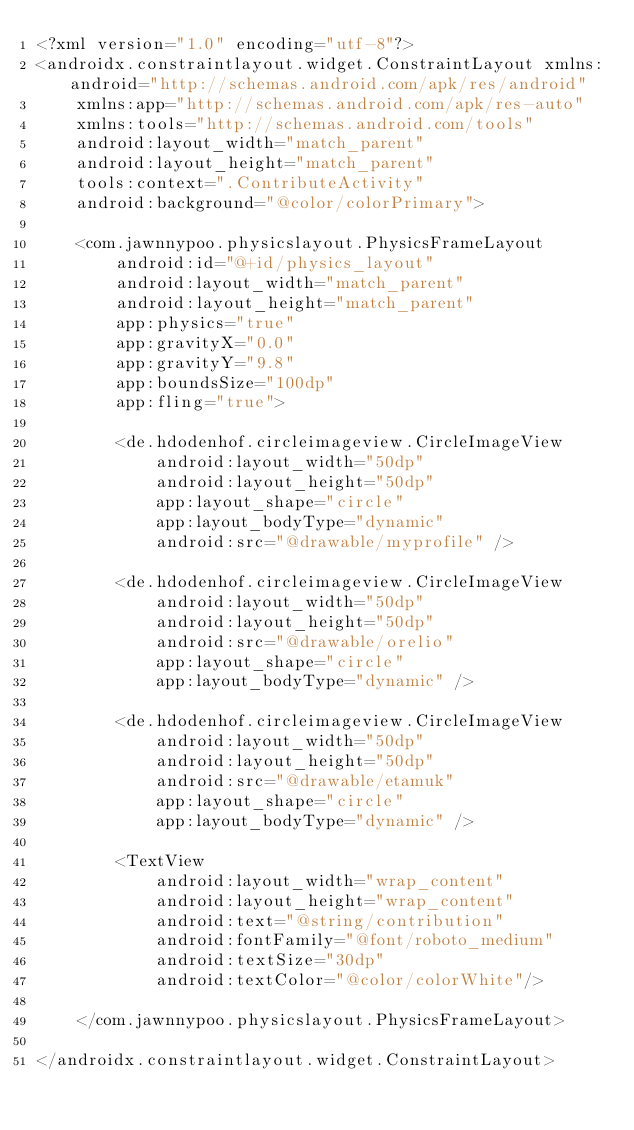Convert code to text. <code><loc_0><loc_0><loc_500><loc_500><_XML_><?xml version="1.0" encoding="utf-8"?>
<androidx.constraintlayout.widget.ConstraintLayout xmlns:android="http://schemas.android.com/apk/res/android"
    xmlns:app="http://schemas.android.com/apk/res-auto"
    xmlns:tools="http://schemas.android.com/tools"
    android:layout_width="match_parent"
    android:layout_height="match_parent"
    tools:context=".ContributeActivity"
    android:background="@color/colorPrimary">

    <com.jawnnypoo.physicslayout.PhysicsFrameLayout
        android:id="@+id/physics_layout"
        android:layout_width="match_parent"
        android:layout_height="match_parent"
        app:physics="true"
        app:gravityX="0.0"
        app:gravityY="9.8"
        app:boundsSize="100dp"
        app:fling="true">

        <de.hdodenhof.circleimageview.CircleImageView
            android:layout_width="50dp"
            android:layout_height="50dp"
            app:layout_shape="circle"
            app:layout_bodyType="dynamic"
            android:src="@drawable/myprofile" />

        <de.hdodenhof.circleimageview.CircleImageView
            android:layout_width="50dp"
            android:layout_height="50dp"
            android:src="@drawable/orelio"
            app:layout_shape="circle"
            app:layout_bodyType="dynamic" />

        <de.hdodenhof.circleimageview.CircleImageView
            android:layout_width="50dp"
            android:layout_height="50dp"
            android:src="@drawable/etamuk"
            app:layout_shape="circle"
            app:layout_bodyType="dynamic" />

        <TextView
            android:layout_width="wrap_content"
            android:layout_height="wrap_content"
            android:text="@string/contribution"
            android:fontFamily="@font/roboto_medium"
            android:textSize="30dp"
            android:textColor="@color/colorWhite"/>

    </com.jawnnypoo.physicslayout.PhysicsFrameLayout>

</androidx.constraintlayout.widget.ConstraintLayout></code> 